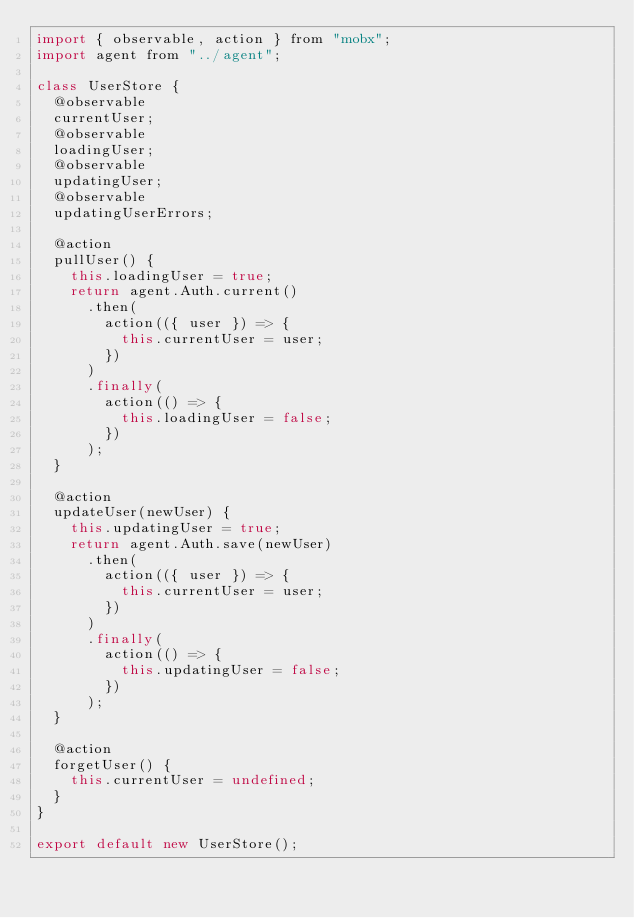Convert code to text. <code><loc_0><loc_0><loc_500><loc_500><_JavaScript_>import { observable, action } from "mobx";
import agent from "../agent";

class UserStore {
  @observable
  currentUser;
  @observable
  loadingUser;
  @observable
  updatingUser;
  @observable
  updatingUserErrors;

  @action
  pullUser() {
    this.loadingUser = true;
    return agent.Auth.current()
      .then(
        action(({ user }) => {
          this.currentUser = user;
        })
      )
      .finally(
        action(() => {
          this.loadingUser = false;
        })
      );
  }

  @action
  updateUser(newUser) {
    this.updatingUser = true;
    return agent.Auth.save(newUser)
      .then(
        action(({ user }) => {
          this.currentUser = user;
        })
      )
      .finally(
        action(() => {
          this.updatingUser = false;
        })
      );
  }

  @action
  forgetUser() {
    this.currentUser = undefined;
  }
}

export default new UserStore();
</code> 